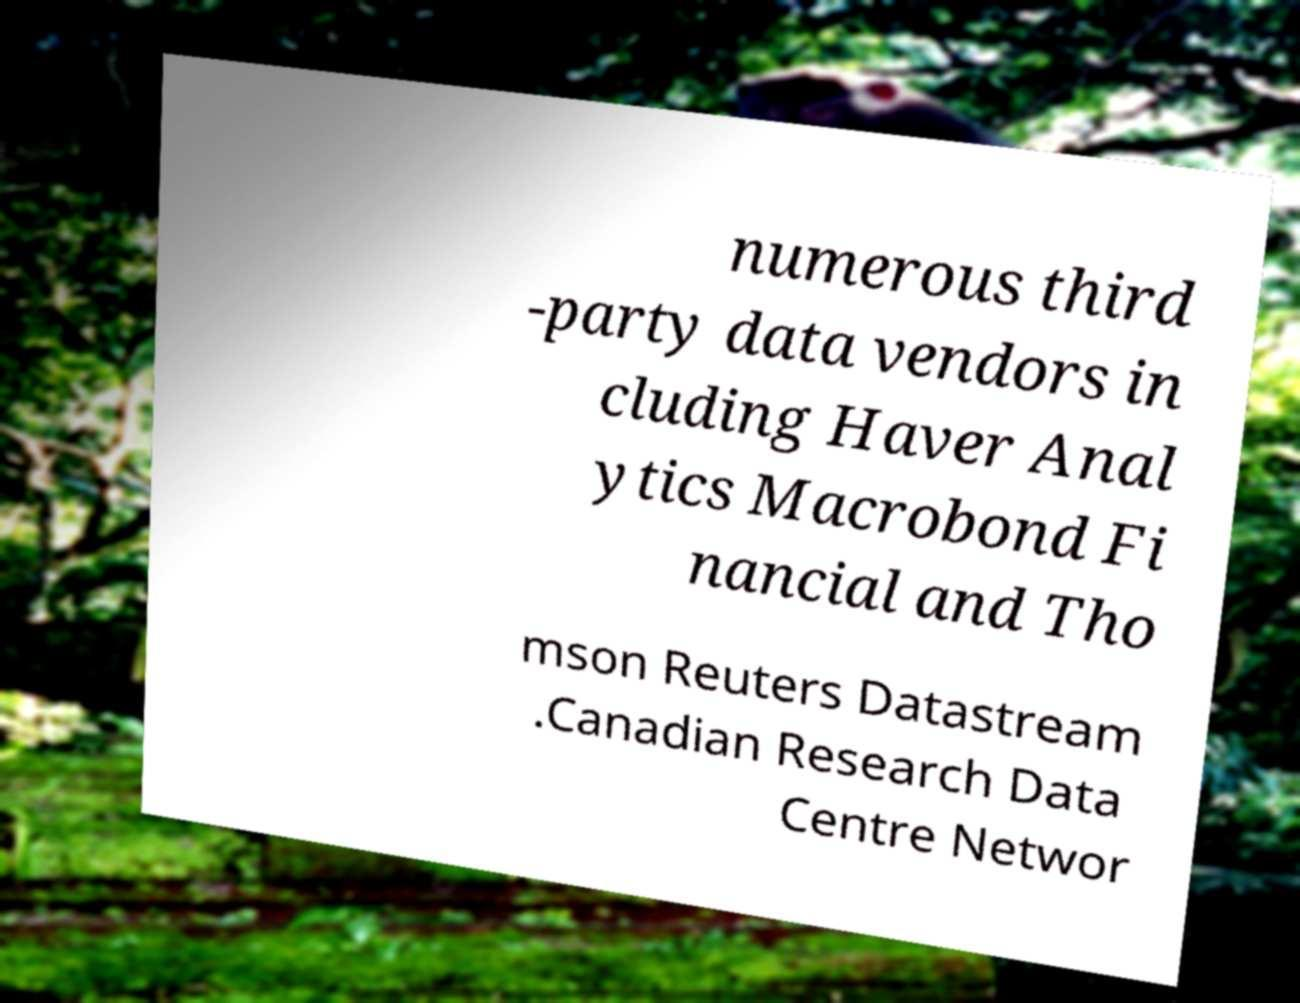Can you read and provide the text displayed in the image?This photo seems to have some interesting text. Can you extract and type it out for me? numerous third -party data vendors in cluding Haver Anal ytics Macrobond Fi nancial and Tho mson Reuters Datastream .Canadian Research Data Centre Networ 